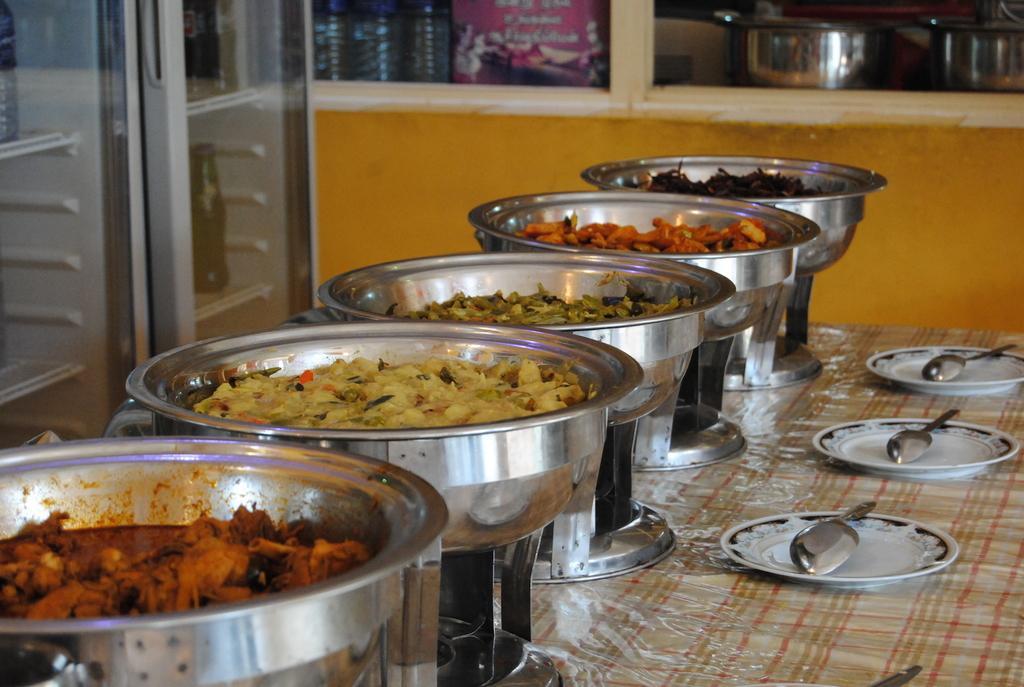Can you describe this image briefly? In this image I can see the food in few vessels. I can see few spoons on the plates. They are on the table. Back I can see the wall, few vessels and few bottles inside the fridge. Food is in red, cream, yellow and black color. 